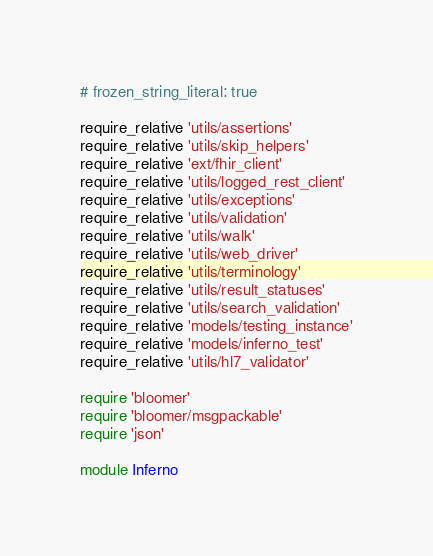<code> <loc_0><loc_0><loc_500><loc_500><_Ruby_># frozen_string_literal: true

require_relative 'utils/assertions'
require_relative 'utils/skip_helpers'
require_relative 'ext/fhir_client'
require_relative 'utils/logged_rest_client'
require_relative 'utils/exceptions'
require_relative 'utils/validation'
require_relative 'utils/walk'
require_relative 'utils/web_driver'
require_relative 'utils/terminology'
require_relative 'utils/result_statuses'
require_relative 'utils/search_validation'
require_relative 'models/testing_instance'
require_relative 'models/inferno_test'
require_relative 'utils/hl7_validator'

require 'bloomer'
require 'bloomer/msgpackable'
require 'json'

module Inferno</code> 